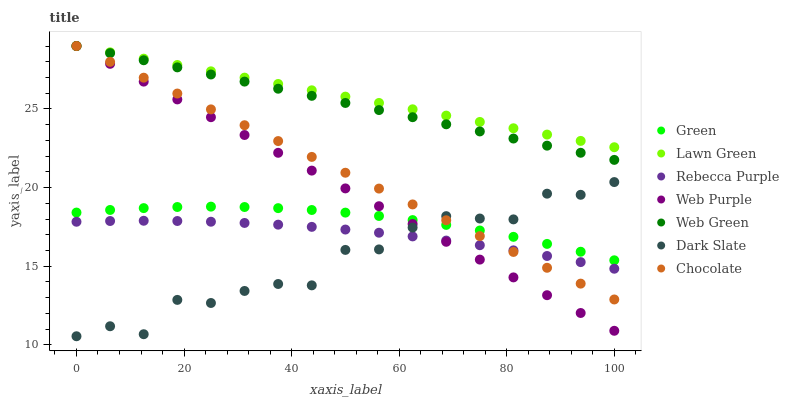Does Dark Slate have the minimum area under the curve?
Answer yes or no. Yes. Does Lawn Green have the maximum area under the curve?
Answer yes or no. Yes. Does Web Green have the minimum area under the curve?
Answer yes or no. No. Does Web Green have the maximum area under the curve?
Answer yes or no. No. Is Lawn Green the smoothest?
Answer yes or no. Yes. Is Dark Slate the roughest?
Answer yes or no. Yes. Is Web Green the smoothest?
Answer yes or no. No. Is Web Green the roughest?
Answer yes or no. No. Does Dark Slate have the lowest value?
Answer yes or no. Yes. Does Web Green have the lowest value?
Answer yes or no. No. Does Web Purple have the highest value?
Answer yes or no. Yes. Does Dark Slate have the highest value?
Answer yes or no. No. Is Rebecca Purple less than Lawn Green?
Answer yes or no. Yes. Is Lawn Green greater than Rebecca Purple?
Answer yes or no. Yes. Does Chocolate intersect Lawn Green?
Answer yes or no. Yes. Is Chocolate less than Lawn Green?
Answer yes or no. No. Is Chocolate greater than Lawn Green?
Answer yes or no. No. Does Rebecca Purple intersect Lawn Green?
Answer yes or no. No. 